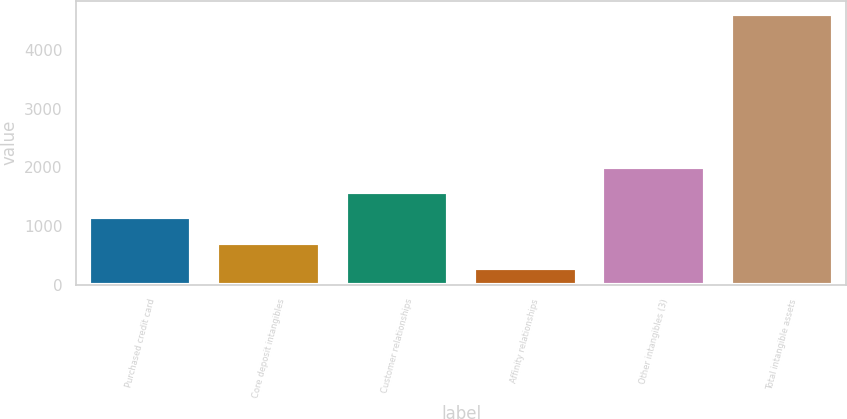Convert chart. <chart><loc_0><loc_0><loc_500><loc_500><bar_chart><fcel>Purchased credit card<fcel>Core deposit intangibles<fcel>Customer relationships<fcel>Affinity relationships<fcel>Other intangibles (3)<fcel>Total intangible assets<nl><fcel>1148<fcel>715<fcel>1581<fcel>282<fcel>2014<fcel>4612<nl></chart> 